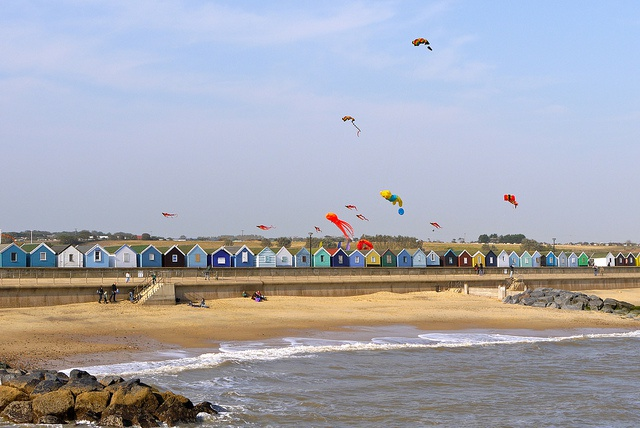Describe the objects in this image and their specific colors. I can see kite in lavender and darkgray tones, people in lavender, gray, white, and tan tones, kite in lavender, red, salmon, and lightpink tones, kite in lavender, olive, blue, gold, and orange tones, and kite in lavender, red, and lightgray tones in this image. 